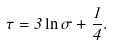<formula> <loc_0><loc_0><loc_500><loc_500>\tau = 3 \ln \sigma + \frac { 1 } { 4 } .</formula> 